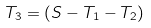Convert formula to latex. <formula><loc_0><loc_0><loc_500><loc_500>T _ { 3 } = ( S - T _ { 1 } - T _ { 2 } )</formula> 